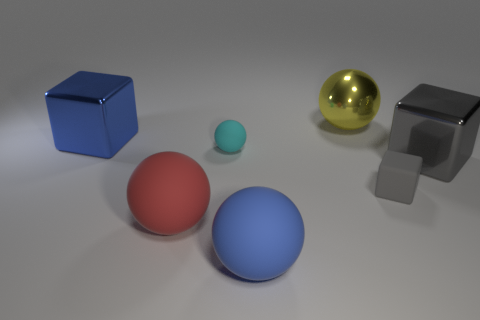There is a object that is to the left of the tiny cyan ball and to the right of the large blue metallic cube; what is its shape?
Offer a very short reply. Sphere. What number of matte objects are the same color as the tiny matte ball?
Offer a terse response. 0. Are there any big blue rubber balls that are behind the gray block on the right side of the tiny object that is on the right side of the yellow thing?
Make the answer very short. No. There is a object that is both behind the small cyan matte ball and on the left side of the large yellow shiny sphere; what is its size?
Offer a terse response. Large. How many blue objects have the same material as the red ball?
Provide a succinct answer. 1. What number of spheres are brown rubber objects or large shiny things?
Ensure brevity in your answer.  1. There is a sphere that is behind the big metal object to the left of the big blue object that is in front of the large blue metallic cube; what is its size?
Offer a terse response. Large. What is the color of the rubber thing that is both to the left of the gray rubber block and behind the red ball?
Your answer should be compact. Cyan. There is a gray shiny cube; is it the same size as the matte ball that is behind the red matte sphere?
Provide a succinct answer. No. The small object that is the same shape as the big yellow metal thing is what color?
Provide a succinct answer. Cyan. 